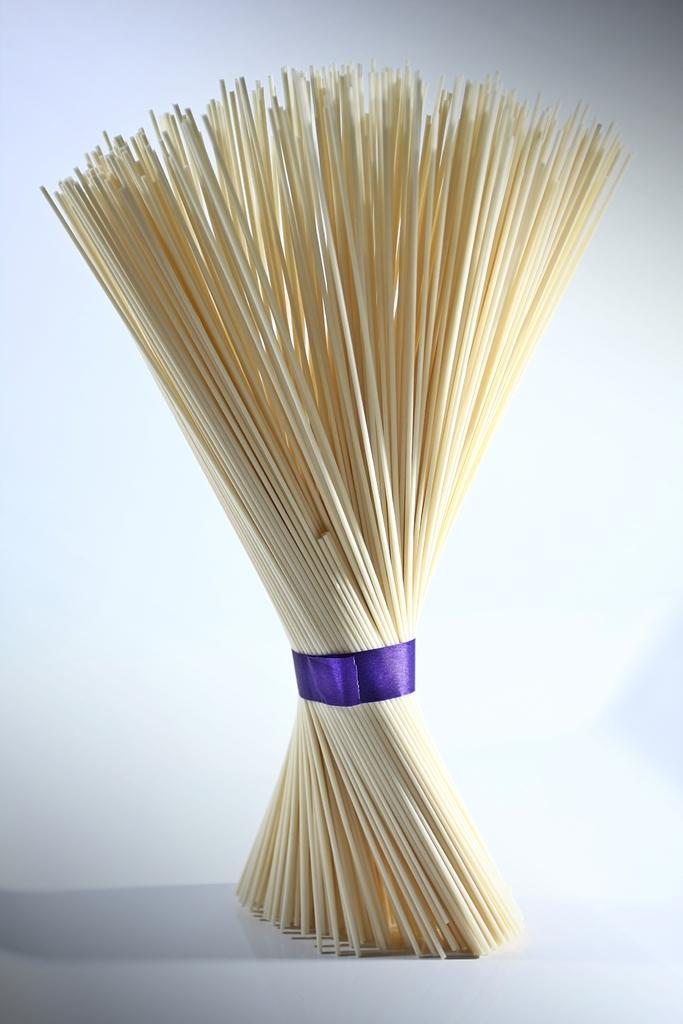How would you summarize this image in a sentence or two? This picture contains broomstick which is tied with blue color ribbon. This is placed on the white color table. In the background, it is white in color. 